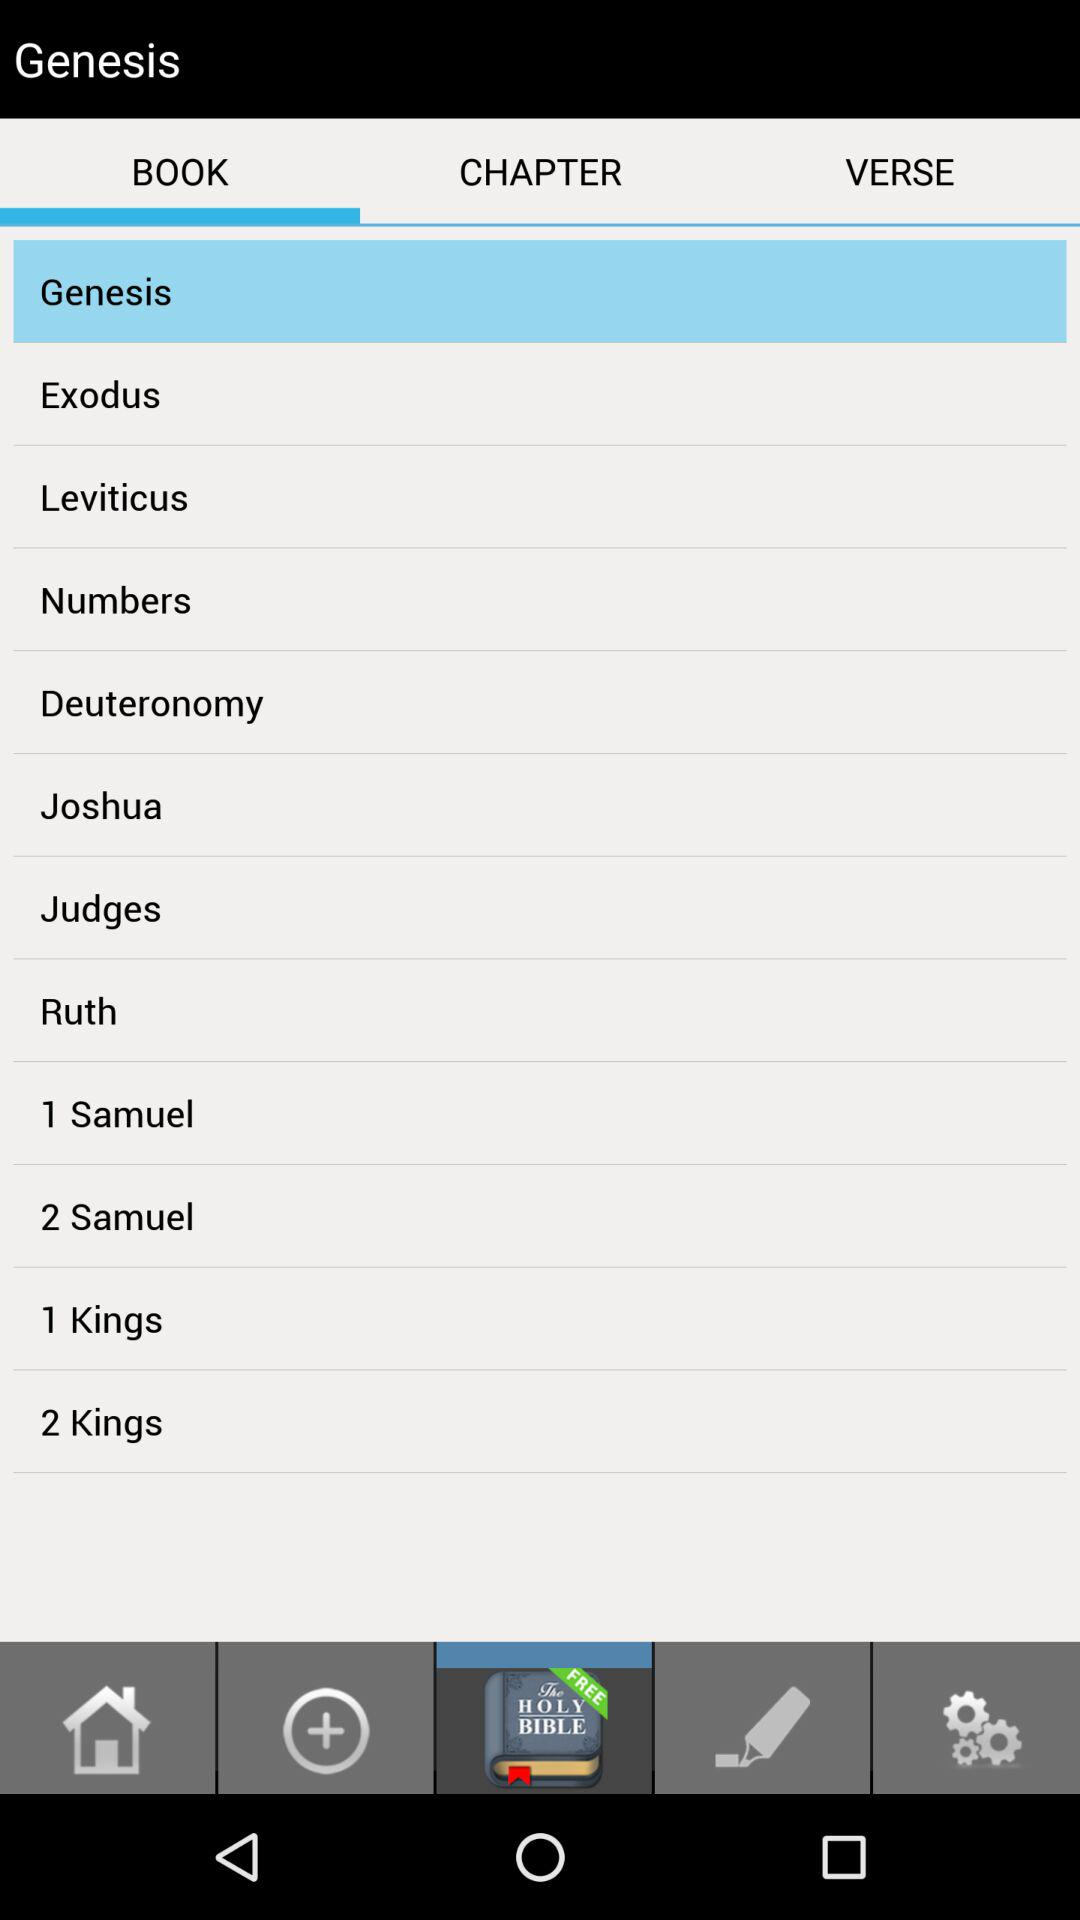What is the selected library in Genesis? The selected library in Genesis is "BOOK". 